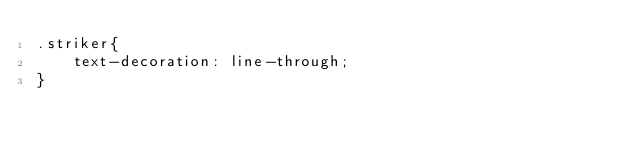Convert code to text. <code><loc_0><loc_0><loc_500><loc_500><_CSS_>.striker{
    text-decoration: line-through;
}</code> 